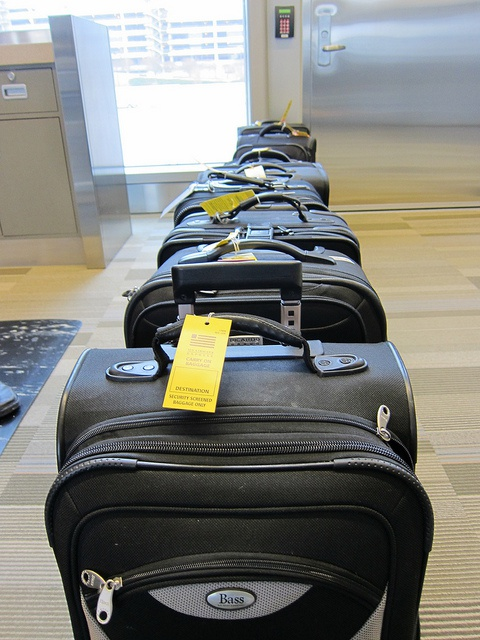Describe the objects in this image and their specific colors. I can see suitcase in white, black, gray, and darkgray tones, suitcase in white, black, gray, darkgray, and lightblue tones, suitcase in white, black, darkgray, and gray tones, suitcase in white, black, gray, and darkgray tones, and suitcase in white, darkgray, and lightblue tones in this image. 